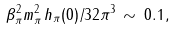Convert formula to latex. <formula><loc_0><loc_0><loc_500><loc_500>\beta _ { \pi } ^ { 2 } m _ { \pi } ^ { 2 } \, h _ { \pi } ( 0 ) / 3 2 \pi ^ { 3 } \, \sim \, 0 . 1 ,</formula> 